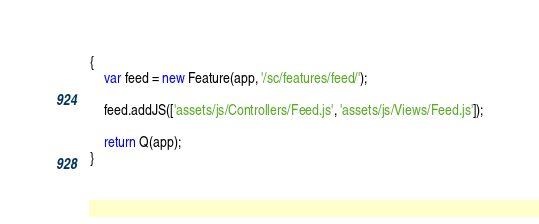Convert code to text. <code><loc_0><loc_0><loc_500><loc_500><_JavaScript_>{
	var feed = new Feature(app, '/sc/features/feed/');

  	feed.addJS(['assets/js/Controllers/Feed.js', 'assets/js/Views/Feed.js']);

	return Q(app);
}
</code> 